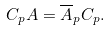<formula> <loc_0><loc_0><loc_500><loc_500>C _ { p } A = \overline { A } _ { p } C _ { p } .</formula> 